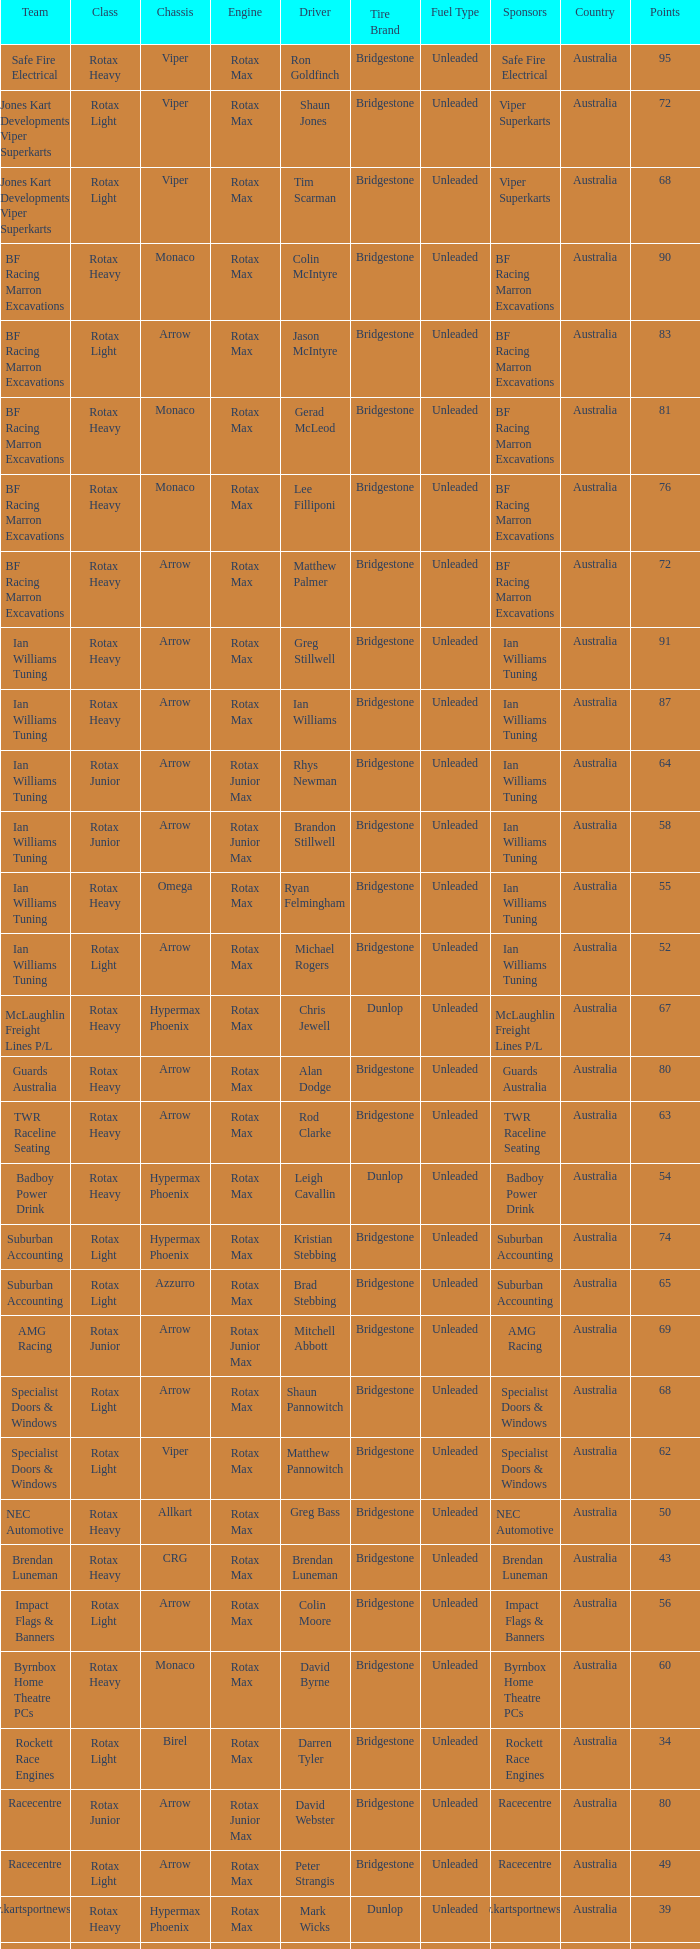Driver Shaun Jones with a viper as a chassis is in what class? Rotax Light. 